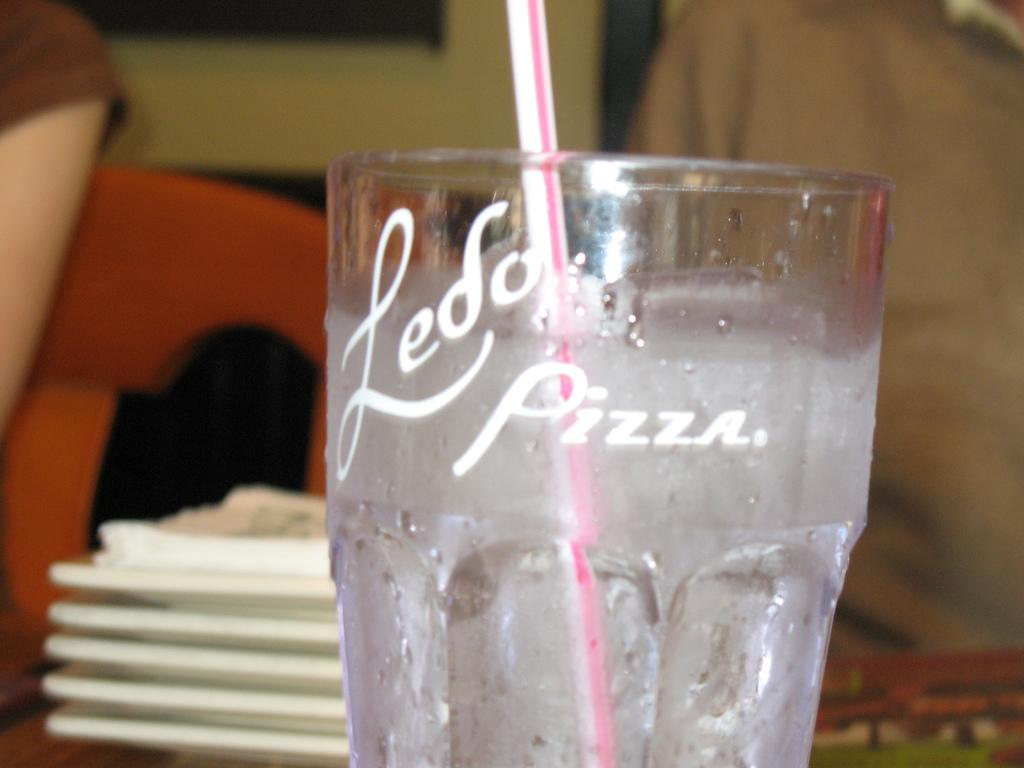Provide a one-sentence caption for the provided image. A glass with clear liquid in it reads "Ledo Pizza.". 